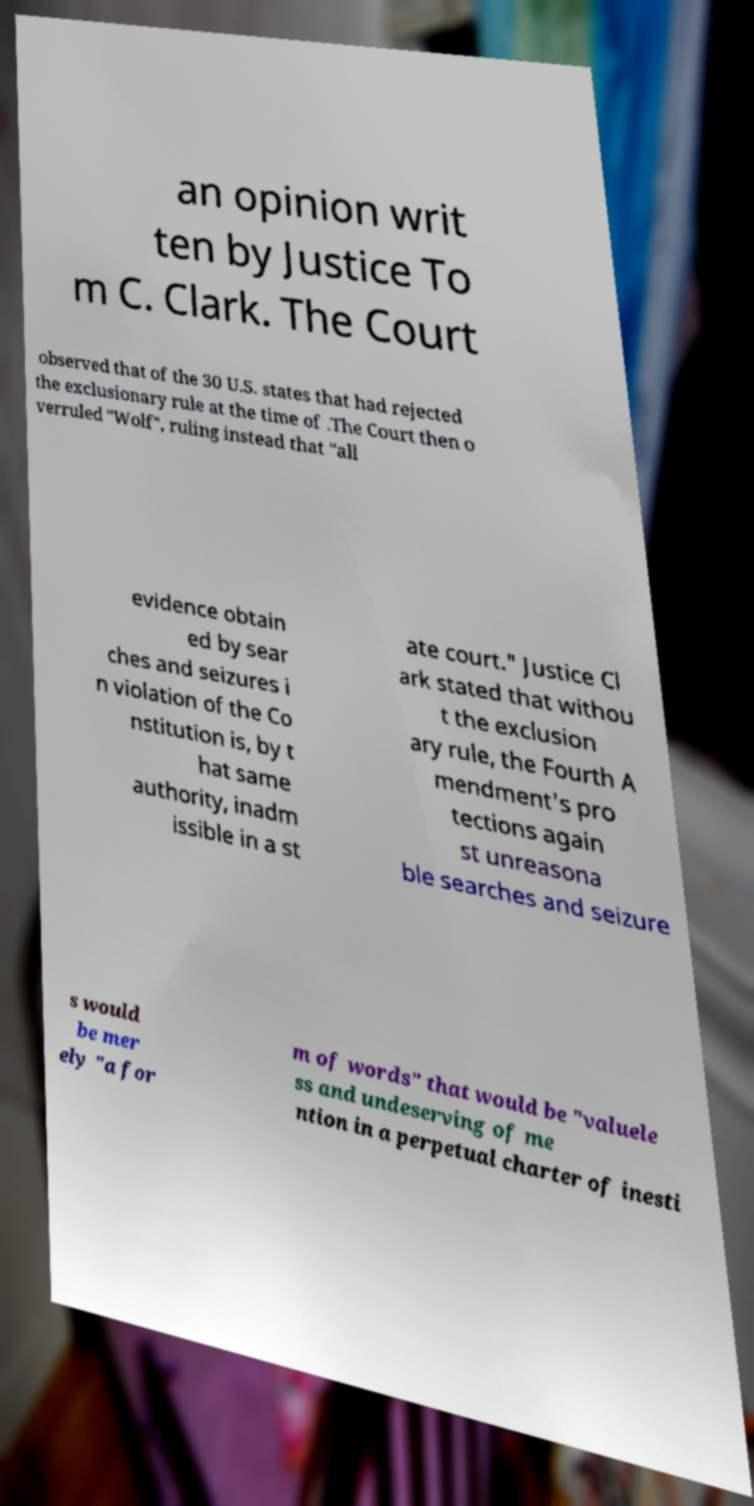Can you read and provide the text displayed in the image?This photo seems to have some interesting text. Can you extract and type it out for me? an opinion writ ten by Justice To m C. Clark. The Court observed that of the 30 U.S. states that had rejected the exclusionary rule at the time of .The Court then o verruled "Wolf", ruling instead that "all evidence obtain ed by sear ches and seizures i n violation of the Co nstitution is, by t hat same authority, inadm issible in a st ate court." Justice Cl ark stated that withou t the exclusion ary rule, the Fourth A mendment's pro tections again st unreasona ble searches and seizure s would be mer ely "a for m of words" that would be "valuele ss and undeserving of me ntion in a perpetual charter of inesti 